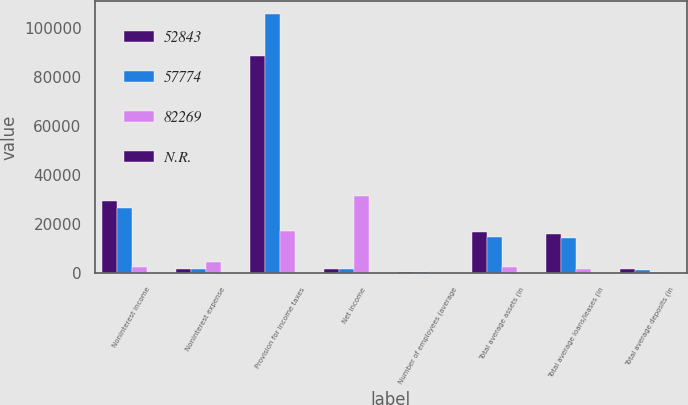<chart> <loc_0><loc_0><loc_500><loc_500><stacked_bar_chart><ecel><fcel>Noninterest income<fcel>Noninterest expense<fcel>Provision for income taxes<fcel>Net income<fcel>Number of employees (average<fcel>Total average assets (in<fcel>Total average loans/leases (in<fcel>Total average deposits (in<nl><fcel>52843<fcel>29257<fcel>1542<fcel>88727<fcel>1542<fcel>298<fcel>16894<fcel>15812<fcel>1496<nl><fcel>57774<fcel>26628<fcel>1542<fcel>105742<fcel>1542<fcel>271<fcel>14591<fcel>14224<fcel>1204<nl><fcel>82269<fcel>2629<fcel>4705<fcel>17015<fcel>31599<fcel>27<fcel>2303<fcel>1588<fcel>292<nl><fcel>N.R.<fcel>10<fcel>3<fcel>16<fcel>16<fcel>10<fcel>16<fcel>11<fcel>24<nl></chart> 